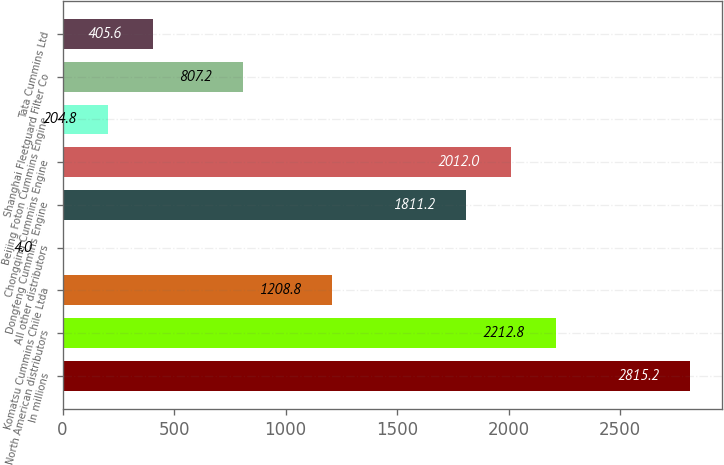Convert chart. <chart><loc_0><loc_0><loc_500><loc_500><bar_chart><fcel>In millions<fcel>North American distributors<fcel>Komatsu Cummins Chile Ltda<fcel>All other distributors<fcel>Dongfeng Cummins Engine<fcel>Chongqing Cummins Engine<fcel>Beijing Foton Cummins Engine<fcel>Shanghai Fleetguard Filter Co<fcel>Tata Cummins Ltd<nl><fcel>2815.2<fcel>2212.8<fcel>1208.8<fcel>4<fcel>1811.2<fcel>2012<fcel>204.8<fcel>807.2<fcel>405.6<nl></chart> 